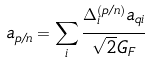Convert formula to latex. <formula><loc_0><loc_0><loc_500><loc_500>a _ { p / n } = \sum _ { i } \cfrac { \Delta ^ { ( p / n ) } _ { i } a _ { q i } } { \sqrt { 2 } G _ { F } }</formula> 